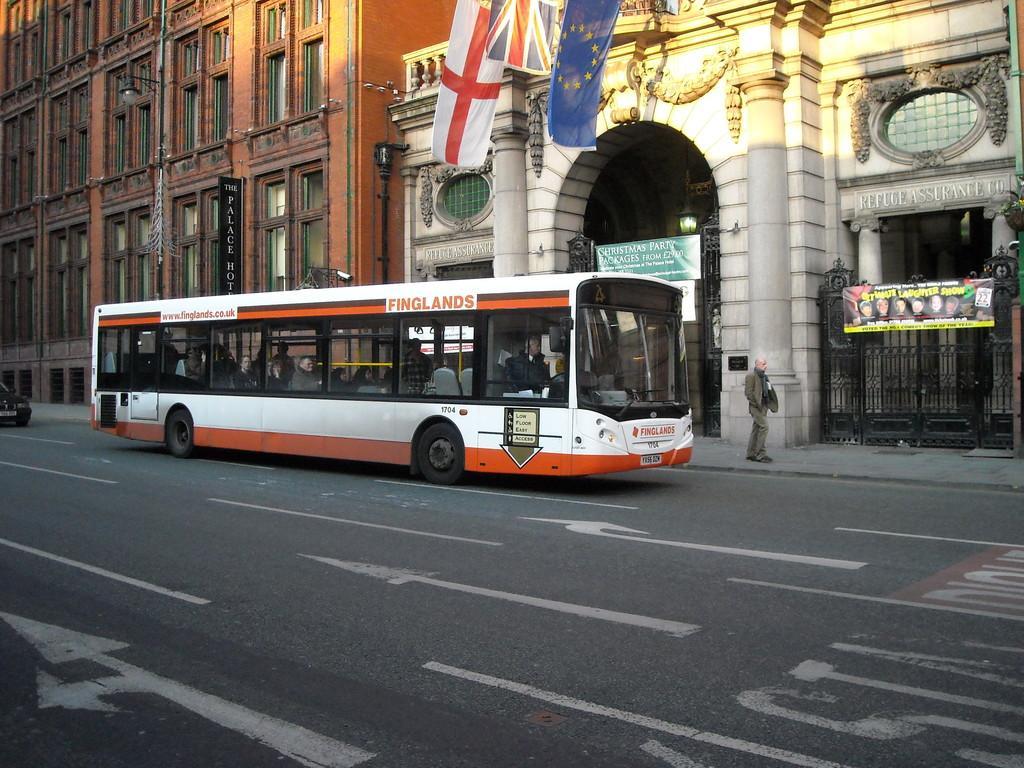Could you give a brief overview of what you see in this image? In this image I can see the vehicles on the road. To the side of the road I can see the person, metal gate and the buildings with boards and the flags. 